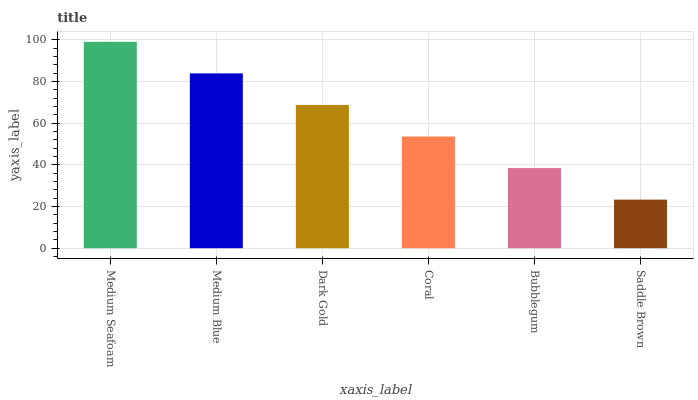Is Medium Blue the minimum?
Answer yes or no. No. Is Medium Blue the maximum?
Answer yes or no. No. Is Medium Seafoam greater than Medium Blue?
Answer yes or no. Yes. Is Medium Blue less than Medium Seafoam?
Answer yes or no. Yes. Is Medium Blue greater than Medium Seafoam?
Answer yes or no. No. Is Medium Seafoam less than Medium Blue?
Answer yes or no. No. Is Dark Gold the high median?
Answer yes or no. Yes. Is Coral the low median?
Answer yes or no. Yes. Is Saddle Brown the high median?
Answer yes or no. No. Is Saddle Brown the low median?
Answer yes or no. No. 